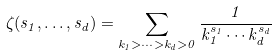<formula> <loc_0><loc_0><loc_500><loc_500>\zeta ( s _ { 1 } , \dots , s _ { d } ) = \sum _ { k _ { 1 } > \dots > k _ { d } > 0 } \frac { 1 } { k _ { 1 } ^ { s _ { 1 } } \cdots k _ { d } ^ { s _ { d } } }</formula> 